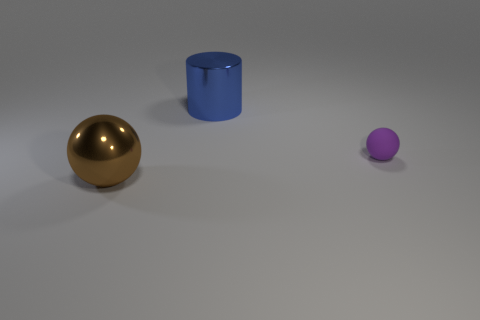Add 3 small yellow spheres. How many objects exist? 6 Subtract all brown balls. How many balls are left? 1 Subtract all cylinders. How many objects are left? 2 Subtract 1 cylinders. How many cylinders are left? 0 Subtract all purple balls. Subtract all brown blocks. How many balls are left? 1 Subtract all brown objects. Subtract all big brown objects. How many objects are left? 1 Add 3 tiny purple matte objects. How many tiny purple matte objects are left? 4 Add 3 purple spheres. How many purple spheres exist? 4 Subtract 0 brown cylinders. How many objects are left? 3 